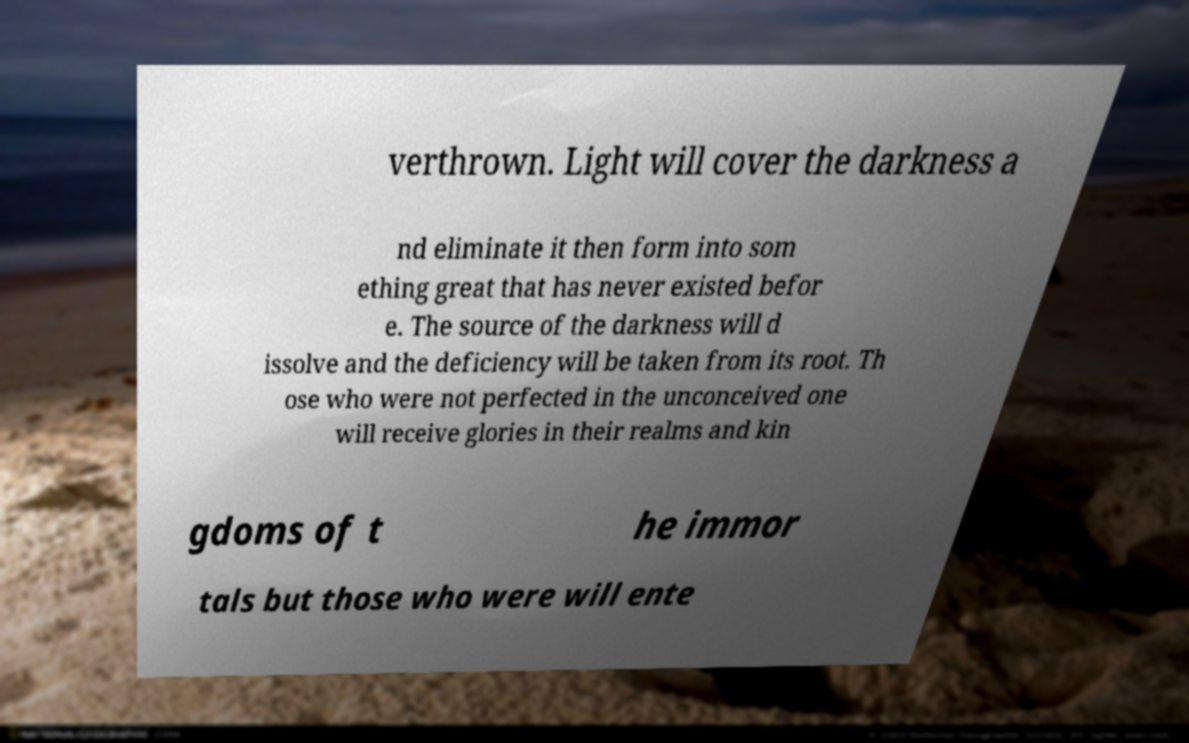Please identify and transcribe the text found in this image. verthrown. Light will cover the darkness a nd eliminate it then form into som ething great that has never existed befor e. The source of the darkness will d issolve and the deficiency will be taken from its root. Th ose who were not perfected in the unconceived one will receive glories in their realms and kin gdoms of t he immor tals but those who were will ente 